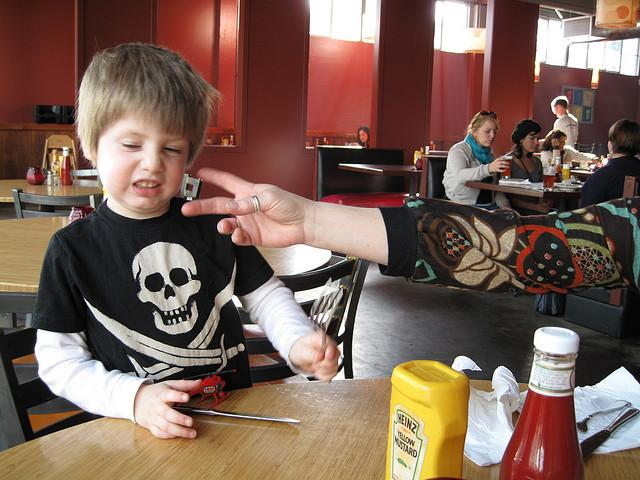Where is the table the boy is sitting at? restaurant 